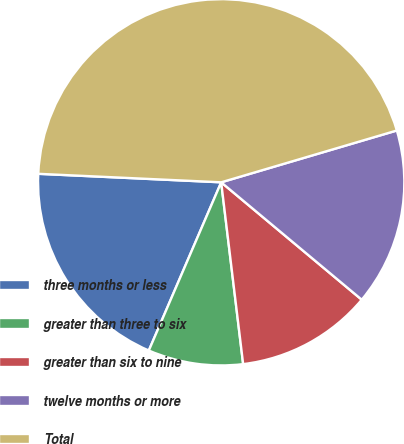Convert chart. <chart><loc_0><loc_0><loc_500><loc_500><pie_chart><fcel>three months or less<fcel>greater than three to six<fcel>greater than six to nine<fcel>twelve months or more<fcel>Total<nl><fcel>19.27%<fcel>8.38%<fcel>12.01%<fcel>15.64%<fcel>44.69%<nl></chart> 